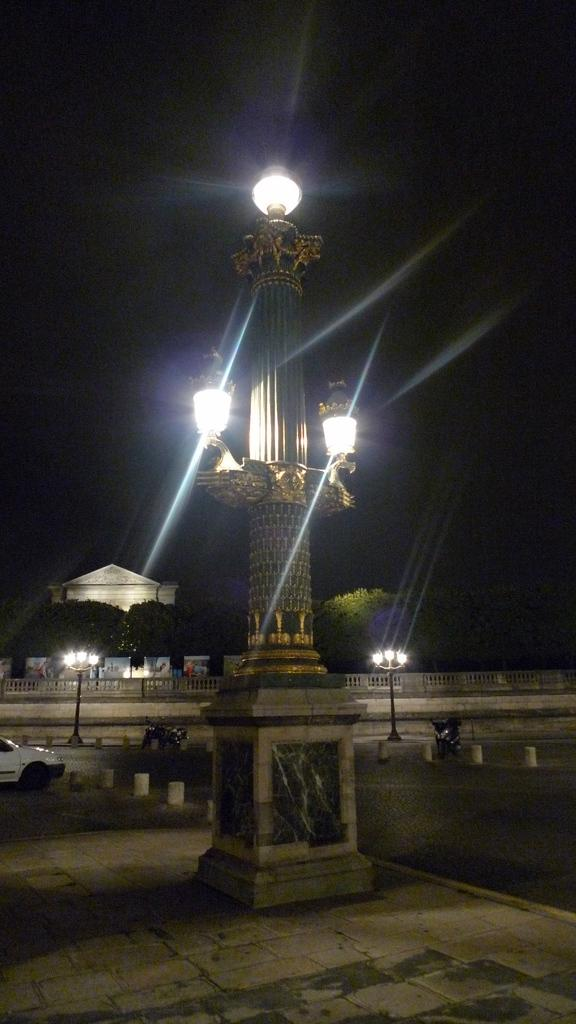What structure is illuminated with lights in the image? There is a tower with lights in the image. What can be seen on the left side of the image? There is a vehicle on the left side of the image. What type of natural vegetation is visible in the image? There are trees visible in the image. What is visible at the top of the image? The sky is visible at the top of the image. What type of bait is being used by the father in the image? There is no father or bait present in the image. What is inside the box that is visible in the image? There is no box present in the image. 